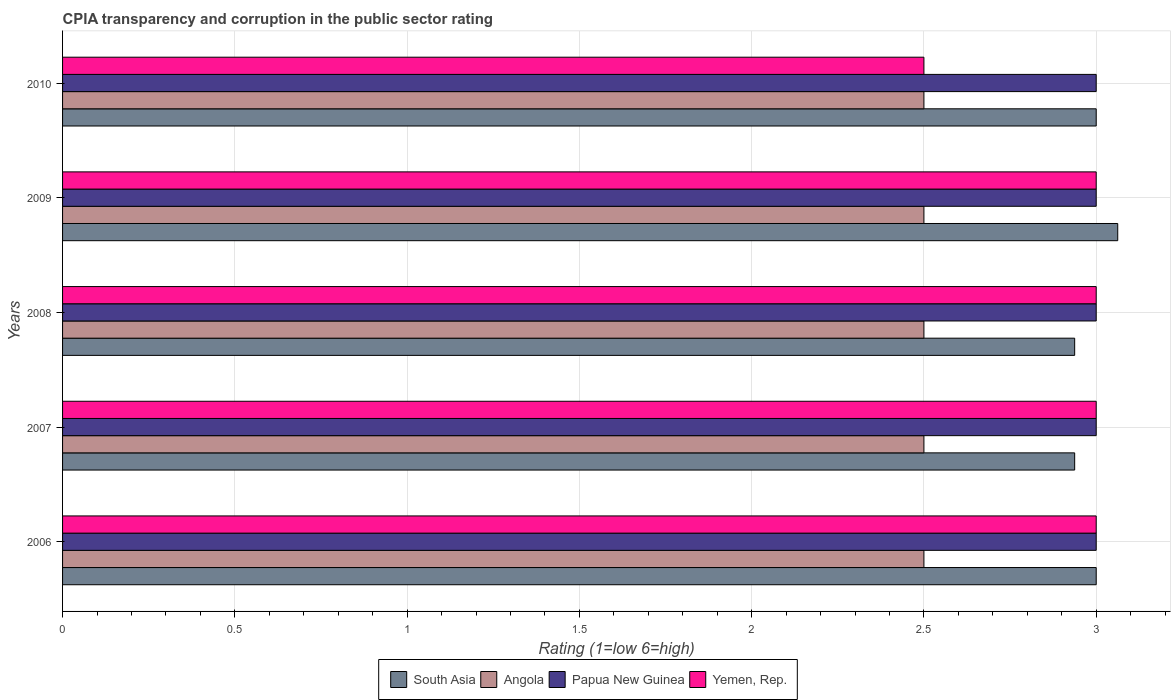How many different coloured bars are there?
Your response must be concise. 4. How many groups of bars are there?
Provide a succinct answer. 5. Are the number of bars on each tick of the Y-axis equal?
Offer a terse response. Yes. What is the label of the 5th group of bars from the top?
Ensure brevity in your answer.  2006. What is the CPIA rating in Angola in 2009?
Your response must be concise. 2.5. Across all years, what is the minimum CPIA rating in Yemen, Rep.?
Offer a very short reply. 2.5. What is the total CPIA rating in South Asia in the graph?
Give a very brief answer. 14.94. What is the difference between the CPIA rating in South Asia in 2008 and that in 2010?
Offer a terse response. -0.06. What is the difference between the CPIA rating in Yemen, Rep. in 2009 and the CPIA rating in Angola in 2007?
Offer a very short reply. 0.5. What is the average CPIA rating in Yemen, Rep. per year?
Provide a succinct answer. 2.9. In the year 2010, what is the difference between the CPIA rating in Papua New Guinea and CPIA rating in Angola?
Your response must be concise. 0.5. What is the ratio of the CPIA rating in Yemen, Rep. in 2006 to that in 2009?
Give a very brief answer. 1. What is the difference between the highest and the second highest CPIA rating in South Asia?
Ensure brevity in your answer.  0.06. What is the difference between the highest and the lowest CPIA rating in Yemen, Rep.?
Provide a short and direct response. 0.5. Is it the case that in every year, the sum of the CPIA rating in Angola and CPIA rating in Yemen, Rep. is greater than the sum of CPIA rating in South Asia and CPIA rating in Papua New Guinea?
Your answer should be very brief. No. What does the 2nd bar from the top in 2008 represents?
Make the answer very short. Papua New Guinea. What does the 4th bar from the bottom in 2009 represents?
Provide a succinct answer. Yemen, Rep. How many bars are there?
Offer a terse response. 20. Are all the bars in the graph horizontal?
Ensure brevity in your answer.  Yes. What is the difference between two consecutive major ticks on the X-axis?
Your answer should be very brief. 0.5. Are the values on the major ticks of X-axis written in scientific E-notation?
Provide a succinct answer. No. Where does the legend appear in the graph?
Make the answer very short. Bottom center. How many legend labels are there?
Provide a succinct answer. 4. How are the legend labels stacked?
Provide a succinct answer. Horizontal. What is the title of the graph?
Your response must be concise. CPIA transparency and corruption in the public sector rating. What is the Rating (1=low 6=high) of South Asia in 2006?
Your response must be concise. 3. What is the Rating (1=low 6=high) of Papua New Guinea in 2006?
Ensure brevity in your answer.  3. What is the Rating (1=low 6=high) of Yemen, Rep. in 2006?
Offer a terse response. 3. What is the Rating (1=low 6=high) of South Asia in 2007?
Offer a very short reply. 2.94. What is the Rating (1=low 6=high) of Papua New Guinea in 2007?
Keep it short and to the point. 3. What is the Rating (1=low 6=high) of Yemen, Rep. in 2007?
Your response must be concise. 3. What is the Rating (1=low 6=high) in South Asia in 2008?
Your answer should be compact. 2.94. What is the Rating (1=low 6=high) in Angola in 2008?
Provide a succinct answer. 2.5. What is the Rating (1=low 6=high) of Papua New Guinea in 2008?
Ensure brevity in your answer.  3. What is the Rating (1=low 6=high) of Yemen, Rep. in 2008?
Ensure brevity in your answer.  3. What is the Rating (1=low 6=high) in South Asia in 2009?
Your answer should be very brief. 3.06. What is the Rating (1=low 6=high) of Yemen, Rep. in 2009?
Your answer should be very brief. 3. What is the Rating (1=low 6=high) of South Asia in 2010?
Your response must be concise. 3. What is the Rating (1=low 6=high) in Angola in 2010?
Keep it short and to the point. 2.5. What is the Rating (1=low 6=high) in Papua New Guinea in 2010?
Provide a succinct answer. 3. What is the Rating (1=low 6=high) of Yemen, Rep. in 2010?
Keep it short and to the point. 2.5. Across all years, what is the maximum Rating (1=low 6=high) of South Asia?
Ensure brevity in your answer.  3.06. Across all years, what is the maximum Rating (1=low 6=high) in Yemen, Rep.?
Keep it short and to the point. 3. Across all years, what is the minimum Rating (1=low 6=high) in South Asia?
Your answer should be compact. 2.94. What is the total Rating (1=low 6=high) in South Asia in the graph?
Offer a very short reply. 14.94. What is the total Rating (1=low 6=high) in Angola in the graph?
Make the answer very short. 12.5. What is the difference between the Rating (1=low 6=high) in South Asia in 2006 and that in 2007?
Provide a short and direct response. 0.06. What is the difference between the Rating (1=low 6=high) of Papua New Guinea in 2006 and that in 2007?
Keep it short and to the point. 0. What is the difference between the Rating (1=low 6=high) in South Asia in 2006 and that in 2008?
Provide a succinct answer. 0.06. What is the difference between the Rating (1=low 6=high) of Papua New Guinea in 2006 and that in 2008?
Give a very brief answer. 0. What is the difference between the Rating (1=low 6=high) of Yemen, Rep. in 2006 and that in 2008?
Offer a very short reply. 0. What is the difference between the Rating (1=low 6=high) of South Asia in 2006 and that in 2009?
Keep it short and to the point. -0.06. What is the difference between the Rating (1=low 6=high) of Angola in 2006 and that in 2009?
Make the answer very short. 0. What is the difference between the Rating (1=low 6=high) of Papua New Guinea in 2006 and that in 2009?
Your response must be concise. 0. What is the difference between the Rating (1=low 6=high) in Yemen, Rep. in 2006 and that in 2009?
Your answer should be compact. 0. What is the difference between the Rating (1=low 6=high) of South Asia in 2006 and that in 2010?
Your response must be concise. 0. What is the difference between the Rating (1=low 6=high) of Angola in 2006 and that in 2010?
Provide a succinct answer. 0. What is the difference between the Rating (1=low 6=high) in Papua New Guinea in 2006 and that in 2010?
Ensure brevity in your answer.  0. What is the difference between the Rating (1=low 6=high) in Yemen, Rep. in 2006 and that in 2010?
Provide a succinct answer. 0.5. What is the difference between the Rating (1=low 6=high) in South Asia in 2007 and that in 2008?
Give a very brief answer. 0. What is the difference between the Rating (1=low 6=high) in Angola in 2007 and that in 2008?
Provide a succinct answer. 0. What is the difference between the Rating (1=low 6=high) of Papua New Guinea in 2007 and that in 2008?
Provide a succinct answer. 0. What is the difference between the Rating (1=low 6=high) of South Asia in 2007 and that in 2009?
Make the answer very short. -0.12. What is the difference between the Rating (1=low 6=high) in Papua New Guinea in 2007 and that in 2009?
Give a very brief answer. 0. What is the difference between the Rating (1=low 6=high) in South Asia in 2007 and that in 2010?
Provide a short and direct response. -0.06. What is the difference between the Rating (1=low 6=high) of Papua New Guinea in 2007 and that in 2010?
Your answer should be compact. 0. What is the difference between the Rating (1=low 6=high) of South Asia in 2008 and that in 2009?
Offer a very short reply. -0.12. What is the difference between the Rating (1=low 6=high) of Angola in 2008 and that in 2009?
Keep it short and to the point. 0. What is the difference between the Rating (1=low 6=high) of Papua New Guinea in 2008 and that in 2009?
Your answer should be compact. 0. What is the difference between the Rating (1=low 6=high) in Yemen, Rep. in 2008 and that in 2009?
Give a very brief answer. 0. What is the difference between the Rating (1=low 6=high) in South Asia in 2008 and that in 2010?
Provide a succinct answer. -0.06. What is the difference between the Rating (1=low 6=high) of Angola in 2008 and that in 2010?
Provide a succinct answer. 0. What is the difference between the Rating (1=low 6=high) of Papua New Guinea in 2008 and that in 2010?
Provide a succinct answer. 0. What is the difference between the Rating (1=low 6=high) of South Asia in 2009 and that in 2010?
Offer a terse response. 0.06. What is the difference between the Rating (1=low 6=high) in Yemen, Rep. in 2009 and that in 2010?
Provide a short and direct response. 0.5. What is the difference between the Rating (1=low 6=high) of South Asia in 2006 and the Rating (1=low 6=high) of Yemen, Rep. in 2007?
Offer a very short reply. 0. What is the difference between the Rating (1=low 6=high) in Angola in 2006 and the Rating (1=low 6=high) in Papua New Guinea in 2007?
Keep it short and to the point. -0.5. What is the difference between the Rating (1=low 6=high) of Papua New Guinea in 2006 and the Rating (1=low 6=high) of Yemen, Rep. in 2007?
Keep it short and to the point. 0. What is the difference between the Rating (1=low 6=high) of South Asia in 2006 and the Rating (1=low 6=high) of Yemen, Rep. in 2008?
Your answer should be compact. 0. What is the difference between the Rating (1=low 6=high) in Angola in 2006 and the Rating (1=low 6=high) in Yemen, Rep. in 2009?
Provide a short and direct response. -0.5. What is the difference between the Rating (1=low 6=high) in South Asia in 2006 and the Rating (1=low 6=high) in Angola in 2010?
Your response must be concise. 0.5. What is the difference between the Rating (1=low 6=high) of South Asia in 2006 and the Rating (1=low 6=high) of Yemen, Rep. in 2010?
Give a very brief answer. 0.5. What is the difference between the Rating (1=low 6=high) in Angola in 2006 and the Rating (1=low 6=high) in Papua New Guinea in 2010?
Your response must be concise. -0.5. What is the difference between the Rating (1=low 6=high) in South Asia in 2007 and the Rating (1=low 6=high) in Angola in 2008?
Keep it short and to the point. 0.44. What is the difference between the Rating (1=low 6=high) of South Asia in 2007 and the Rating (1=low 6=high) of Papua New Guinea in 2008?
Ensure brevity in your answer.  -0.06. What is the difference between the Rating (1=low 6=high) of South Asia in 2007 and the Rating (1=low 6=high) of Yemen, Rep. in 2008?
Provide a short and direct response. -0.06. What is the difference between the Rating (1=low 6=high) of South Asia in 2007 and the Rating (1=low 6=high) of Angola in 2009?
Keep it short and to the point. 0.44. What is the difference between the Rating (1=low 6=high) in South Asia in 2007 and the Rating (1=low 6=high) in Papua New Guinea in 2009?
Ensure brevity in your answer.  -0.06. What is the difference between the Rating (1=low 6=high) in South Asia in 2007 and the Rating (1=low 6=high) in Yemen, Rep. in 2009?
Your answer should be very brief. -0.06. What is the difference between the Rating (1=low 6=high) in Angola in 2007 and the Rating (1=low 6=high) in Papua New Guinea in 2009?
Ensure brevity in your answer.  -0.5. What is the difference between the Rating (1=low 6=high) of Angola in 2007 and the Rating (1=low 6=high) of Yemen, Rep. in 2009?
Offer a very short reply. -0.5. What is the difference between the Rating (1=low 6=high) of Papua New Guinea in 2007 and the Rating (1=low 6=high) of Yemen, Rep. in 2009?
Your answer should be very brief. 0. What is the difference between the Rating (1=low 6=high) in South Asia in 2007 and the Rating (1=low 6=high) in Angola in 2010?
Your answer should be compact. 0.44. What is the difference between the Rating (1=low 6=high) of South Asia in 2007 and the Rating (1=low 6=high) of Papua New Guinea in 2010?
Keep it short and to the point. -0.06. What is the difference between the Rating (1=low 6=high) in South Asia in 2007 and the Rating (1=low 6=high) in Yemen, Rep. in 2010?
Give a very brief answer. 0.44. What is the difference between the Rating (1=low 6=high) of Angola in 2007 and the Rating (1=low 6=high) of Papua New Guinea in 2010?
Provide a succinct answer. -0.5. What is the difference between the Rating (1=low 6=high) in South Asia in 2008 and the Rating (1=low 6=high) in Angola in 2009?
Give a very brief answer. 0.44. What is the difference between the Rating (1=low 6=high) in South Asia in 2008 and the Rating (1=low 6=high) in Papua New Guinea in 2009?
Your response must be concise. -0.06. What is the difference between the Rating (1=low 6=high) in South Asia in 2008 and the Rating (1=low 6=high) in Yemen, Rep. in 2009?
Give a very brief answer. -0.06. What is the difference between the Rating (1=low 6=high) of South Asia in 2008 and the Rating (1=low 6=high) of Angola in 2010?
Provide a succinct answer. 0.44. What is the difference between the Rating (1=low 6=high) of South Asia in 2008 and the Rating (1=low 6=high) of Papua New Guinea in 2010?
Your answer should be very brief. -0.06. What is the difference between the Rating (1=low 6=high) of South Asia in 2008 and the Rating (1=low 6=high) of Yemen, Rep. in 2010?
Make the answer very short. 0.44. What is the difference between the Rating (1=low 6=high) of Angola in 2008 and the Rating (1=low 6=high) of Papua New Guinea in 2010?
Provide a succinct answer. -0.5. What is the difference between the Rating (1=low 6=high) of Papua New Guinea in 2008 and the Rating (1=low 6=high) of Yemen, Rep. in 2010?
Ensure brevity in your answer.  0.5. What is the difference between the Rating (1=low 6=high) of South Asia in 2009 and the Rating (1=low 6=high) of Angola in 2010?
Make the answer very short. 0.56. What is the difference between the Rating (1=low 6=high) in South Asia in 2009 and the Rating (1=low 6=high) in Papua New Guinea in 2010?
Ensure brevity in your answer.  0.06. What is the difference between the Rating (1=low 6=high) in South Asia in 2009 and the Rating (1=low 6=high) in Yemen, Rep. in 2010?
Your response must be concise. 0.56. What is the difference between the Rating (1=low 6=high) of Angola in 2009 and the Rating (1=low 6=high) of Yemen, Rep. in 2010?
Provide a succinct answer. 0. What is the difference between the Rating (1=low 6=high) in Papua New Guinea in 2009 and the Rating (1=low 6=high) in Yemen, Rep. in 2010?
Your answer should be compact. 0.5. What is the average Rating (1=low 6=high) of South Asia per year?
Provide a short and direct response. 2.99. What is the average Rating (1=low 6=high) in Papua New Guinea per year?
Your response must be concise. 3. In the year 2006, what is the difference between the Rating (1=low 6=high) in South Asia and Rating (1=low 6=high) in Papua New Guinea?
Provide a succinct answer. 0. In the year 2006, what is the difference between the Rating (1=low 6=high) of South Asia and Rating (1=low 6=high) of Yemen, Rep.?
Your answer should be very brief. 0. In the year 2006, what is the difference between the Rating (1=low 6=high) in Angola and Rating (1=low 6=high) in Papua New Guinea?
Provide a succinct answer. -0.5. In the year 2006, what is the difference between the Rating (1=low 6=high) of Angola and Rating (1=low 6=high) of Yemen, Rep.?
Provide a succinct answer. -0.5. In the year 2006, what is the difference between the Rating (1=low 6=high) in Papua New Guinea and Rating (1=low 6=high) in Yemen, Rep.?
Provide a short and direct response. 0. In the year 2007, what is the difference between the Rating (1=low 6=high) of South Asia and Rating (1=low 6=high) of Angola?
Provide a succinct answer. 0.44. In the year 2007, what is the difference between the Rating (1=low 6=high) in South Asia and Rating (1=low 6=high) in Papua New Guinea?
Offer a terse response. -0.06. In the year 2007, what is the difference between the Rating (1=low 6=high) in South Asia and Rating (1=low 6=high) in Yemen, Rep.?
Keep it short and to the point. -0.06. In the year 2007, what is the difference between the Rating (1=low 6=high) of Papua New Guinea and Rating (1=low 6=high) of Yemen, Rep.?
Make the answer very short. 0. In the year 2008, what is the difference between the Rating (1=low 6=high) in South Asia and Rating (1=low 6=high) in Angola?
Your answer should be compact. 0.44. In the year 2008, what is the difference between the Rating (1=low 6=high) of South Asia and Rating (1=low 6=high) of Papua New Guinea?
Give a very brief answer. -0.06. In the year 2008, what is the difference between the Rating (1=low 6=high) of South Asia and Rating (1=low 6=high) of Yemen, Rep.?
Ensure brevity in your answer.  -0.06. In the year 2008, what is the difference between the Rating (1=low 6=high) of Angola and Rating (1=low 6=high) of Papua New Guinea?
Ensure brevity in your answer.  -0.5. In the year 2008, what is the difference between the Rating (1=low 6=high) of Angola and Rating (1=low 6=high) of Yemen, Rep.?
Your answer should be compact. -0.5. In the year 2008, what is the difference between the Rating (1=low 6=high) in Papua New Guinea and Rating (1=low 6=high) in Yemen, Rep.?
Give a very brief answer. 0. In the year 2009, what is the difference between the Rating (1=low 6=high) in South Asia and Rating (1=low 6=high) in Angola?
Your answer should be very brief. 0.56. In the year 2009, what is the difference between the Rating (1=low 6=high) in South Asia and Rating (1=low 6=high) in Papua New Guinea?
Provide a succinct answer. 0.06. In the year 2009, what is the difference between the Rating (1=low 6=high) in South Asia and Rating (1=low 6=high) in Yemen, Rep.?
Offer a very short reply. 0.06. In the year 2010, what is the difference between the Rating (1=low 6=high) in South Asia and Rating (1=low 6=high) in Angola?
Make the answer very short. 0.5. In the year 2010, what is the difference between the Rating (1=low 6=high) in South Asia and Rating (1=low 6=high) in Papua New Guinea?
Provide a short and direct response. 0. In the year 2010, what is the difference between the Rating (1=low 6=high) of South Asia and Rating (1=low 6=high) of Yemen, Rep.?
Ensure brevity in your answer.  0.5. In the year 2010, what is the difference between the Rating (1=low 6=high) of Angola and Rating (1=low 6=high) of Yemen, Rep.?
Keep it short and to the point. 0. In the year 2010, what is the difference between the Rating (1=low 6=high) of Papua New Guinea and Rating (1=low 6=high) of Yemen, Rep.?
Provide a succinct answer. 0.5. What is the ratio of the Rating (1=low 6=high) of South Asia in 2006 to that in 2007?
Your answer should be compact. 1.02. What is the ratio of the Rating (1=low 6=high) of Papua New Guinea in 2006 to that in 2007?
Ensure brevity in your answer.  1. What is the ratio of the Rating (1=low 6=high) of South Asia in 2006 to that in 2008?
Ensure brevity in your answer.  1.02. What is the ratio of the Rating (1=low 6=high) of Angola in 2006 to that in 2008?
Your answer should be compact. 1. What is the ratio of the Rating (1=low 6=high) of Papua New Guinea in 2006 to that in 2008?
Keep it short and to the point. 1. What is the ratio of the Rating (1=low 6=high) of Yemen, Rep. in 2006 to that in 2008?
Make the answer very short. 1. What is the ratio of the Rating (1=low 6=high) of South Asia in 2006 to that in 2009?
Provide a succinct answer. 0.98. What is the ratio of the Rating (1=low 6=high) in Angola in 2006 to that in 2009?
Offer a very short reply. 1. What is the ratio of the Rating (1=low 6=high) of Papua New Guinea in 2006 to that in 2009?
Provide a succinct answer. 1. What is the ratio of the Rating (1=low 6=high) of Yemen, Rep. in 2006 to that in 2009?
Offer a terse response. 1. What is the ratio of the Rating (1=low 6=high) of Yemen, Rep. in 2006 to that in 2010?
Keep it short and to the point. 1.2. What is the ratio of the Rating (1=low 6=high) of Angola in 2007 to that in 2008?
Make the answer very short. 1. What is the ratio of the Rating (1=low 6=high) in South Asia in 2007 to that in 2009?
Provide a succinct answer. 0.96. What is the ratio of the Rating (1=low 6=high) in Angola in 2007 to that in 2009?
Provide a short and direct response. 1. What is the ratio of the Rating (1=low 6=high) of Papua New Guinea in 2007 to that in 2009?
Your response must be concise. 1. What is the ratio of the Rating (1=low 6=high) in South Asia in 2007 to that in 2010?
Your answer should be compact. 0.98. What is the ratio of the Rating (1=low 6=high) of Angola in 2007 to that in 2010?
Offer a terse response. 1. What is the ratio of the Rating (1=low 6=high) of South Asia in 2008 to that in 2009?
Your answer should be compact. 0.96. What is the ratio of the Rating (1=low 6=high) of Papua New Guinea in 2008 to that in 2009?
Offer a terse response. 1. What is the ratio of the Rating (1=low 6=high) of Yemen, Rep. in 2008 to that in 2009?
Provide a short and direct response. 1. What is the ratio of the Rating (1=low 6=high) in South Asia in 2008 to that in 2010?
Your answer should be very brief. 0.98. What is the ratio of the Rating (1=low 6=high) in Angola in 2008 to that in 2010?
Ensure brevity in your answer.  1. What is the ratio of the Rating (1=low 6=high) in Yemen, Rep. in 2008 to that in 2010?
Your answer should be compact. 1.2. What is the ratio of the Rating (1=low 6=high) of South Asia in 2009 to that in 2010?
Your answer should be very brief. 1.02. What is the ratio of the Rating (1=low 6=high) in Angola in 2009 to that in 2010?
Make the answer very short. 1. What is the ratio of the Rating (1=low 6=high) in Yemen, Rep. in 2009 to that in 2010?
Make the answer very short. 1.2. What is the difference between the highest and the second highest Rating (1=low 6=high) in South Asia?
Your response must be concise. 0.06. What is the difference between the highest and the second highest Rating (1=low 6=high) in Papua New Guinea?
Your response must be concise. 0. What is the difference between the highest and the lowest Rating (1=low 6=high) of Yemen, Rep.?
Offer a very short reply. 0.5. 